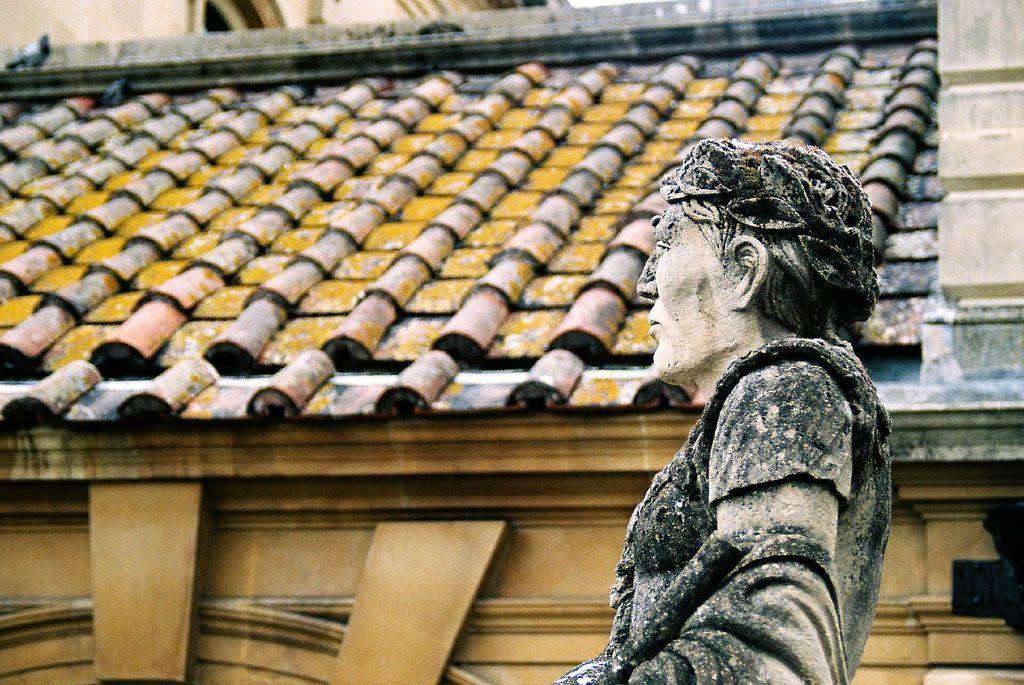What is the main subject in the image? There is a statue in the image. What else can be seen in the image besides the statue? There are buildings in the image. Can you describe the pigeon in the image? There is a pigeon on a rooftop in the image. What type of oven is being used by the partner in the image? There is no partner or oven present in the image. 